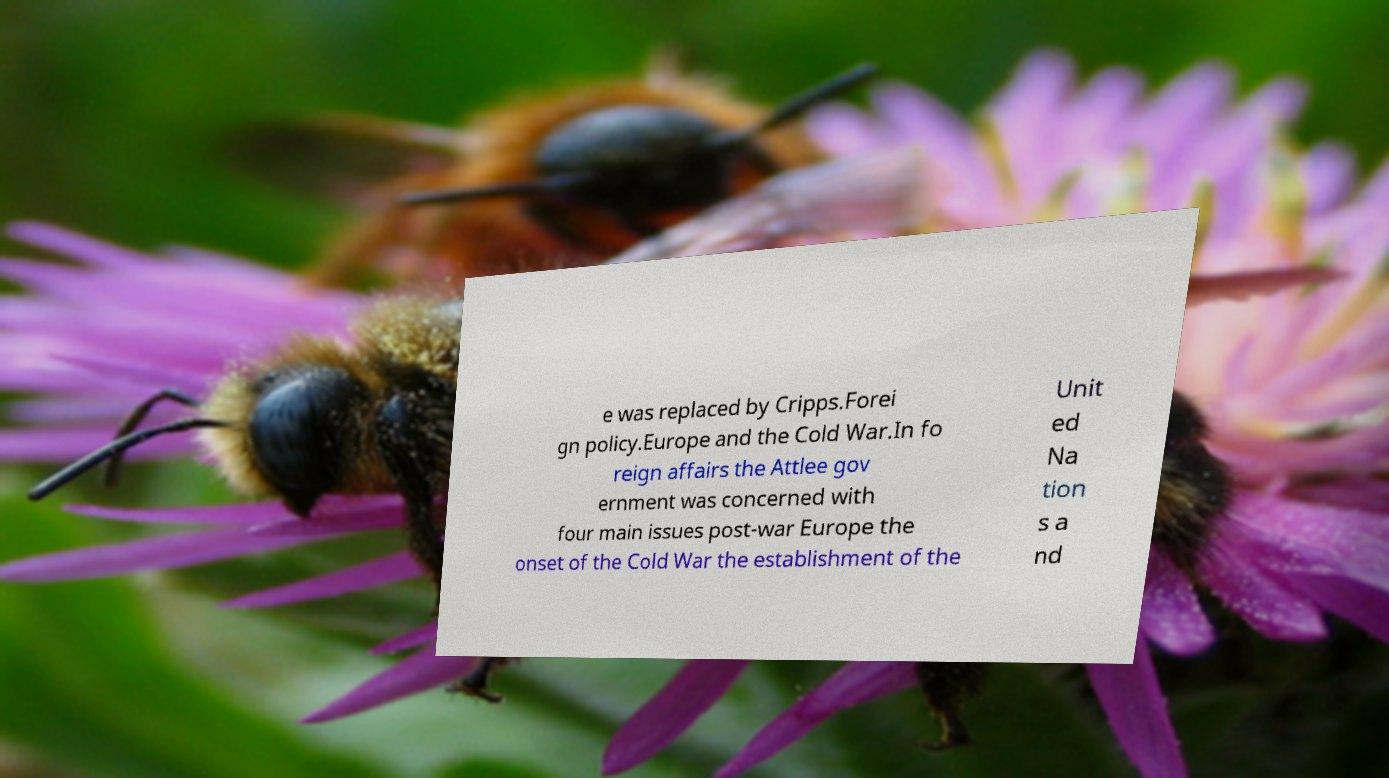For documentation purposes, I need the text within this image transcribed. Could you provide that? e was replaced by Cripps.Forei gn policy.Europe and the Cold War.In fo reign affairs the Attlee gov ernment was concerned with four main issues post-war Europe the onset of the Cold War the establishment of the Unit ed Na tion s a nd 